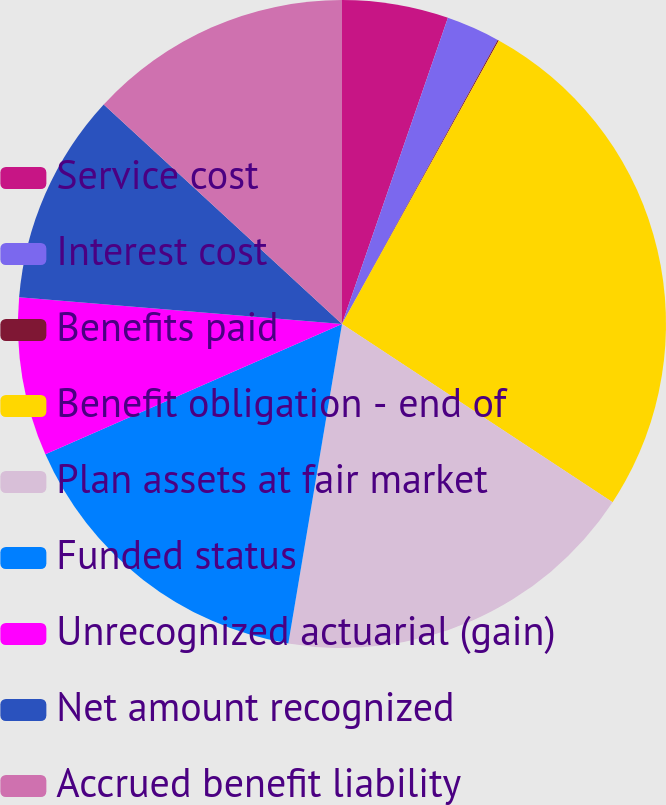<chart> <loc_0><loc_0><loc_500><loc_500><pie_chart><fcel>Service cost<fcel>Interest cost<fcel>Benefits paid<fcel>Benefit obligation - end of<fcel>Plan assets at fair market<fcel>Funded status<fcel>Unrecognized actuarial (gain)<fcel>Net amount recognized<fcel>Accrued benefit liability<nl><fcel>5.3%<fcel>2.68%<fcel>0.06%<fcel>26.23%<fcel>18.38%<fcel>15.76%<fcel>7.91%<fcel>10.53%<fcel>13.15%<nl></chart> 